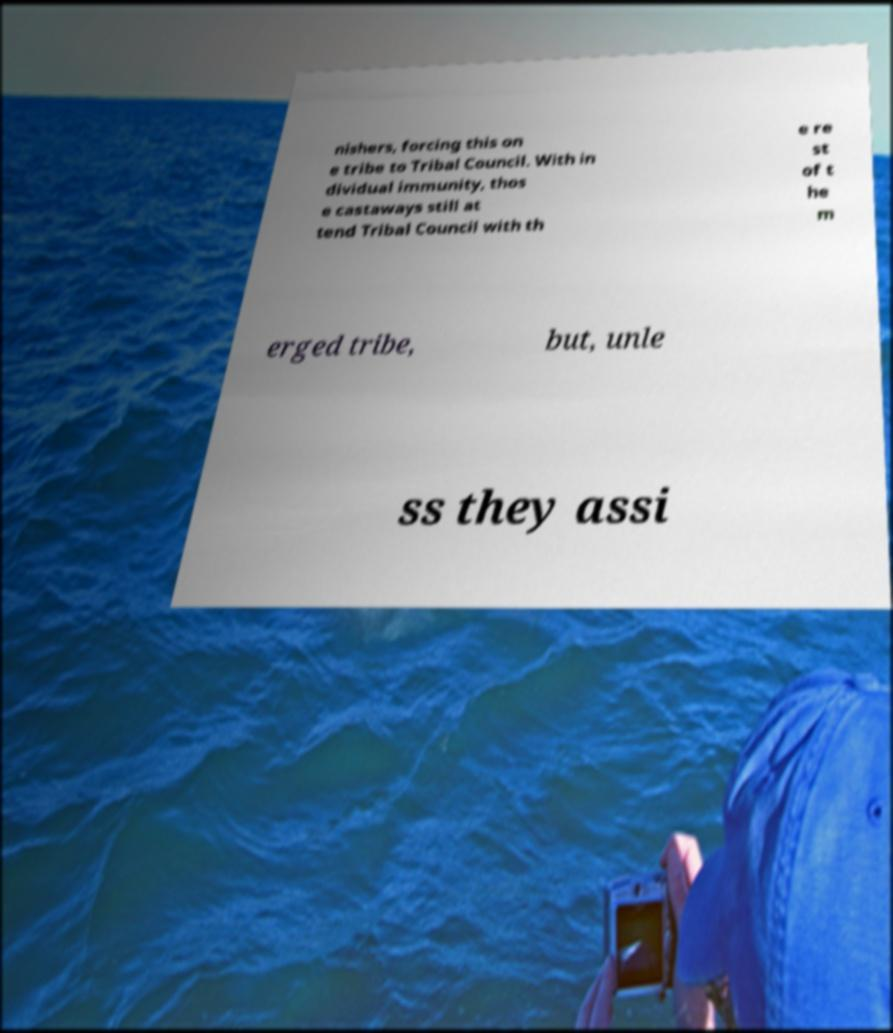There's text embedded in this image that I need extracted. Can you transcribe it verbatim? nishers, forcing this on e tribe to Tribal Council. With in dividual immunity, thos e castaways still at tend Tribal Council with th e re st of t he m erged tribe, but, unle ss they assi 